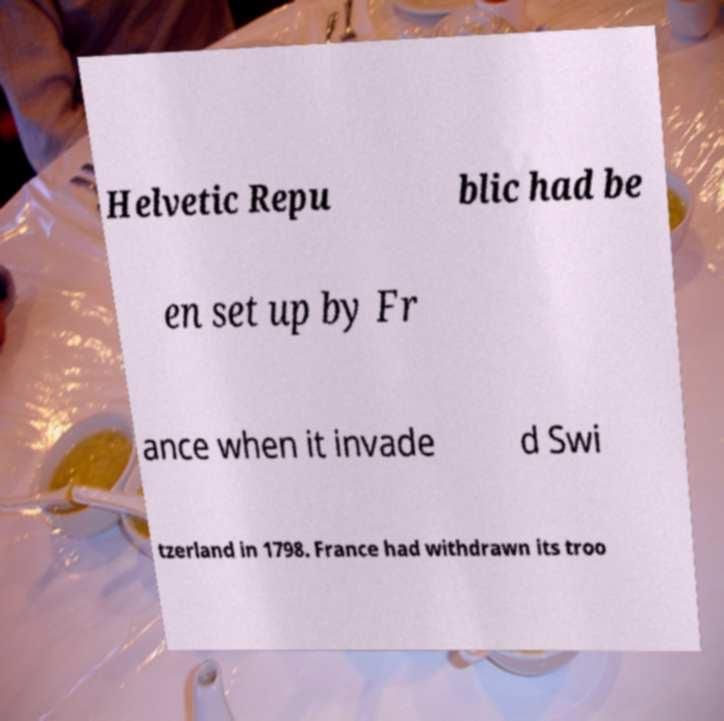There's text embedded in this image that I need extracted. Can you transcribe it verbatim? Helvetic Repu blic had be en set up by Fr ance when it invade d Swi tzerland in 1798. France had withdrawn its troo 